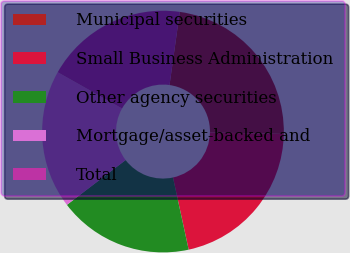<chart> <loc_0><loc_0><loc_500><loc_500><pie_chart><fcel>Municipal securities<fcel>Small Business Administration<fcel>Other agency securities<fcel>Mortgage/asset-backed and<fcel>Total<nl><fcel>23.09%<fcel>21.28%<fcel>18.04%<fcel>18.54%<fcel>19.05%<nl></chart> 